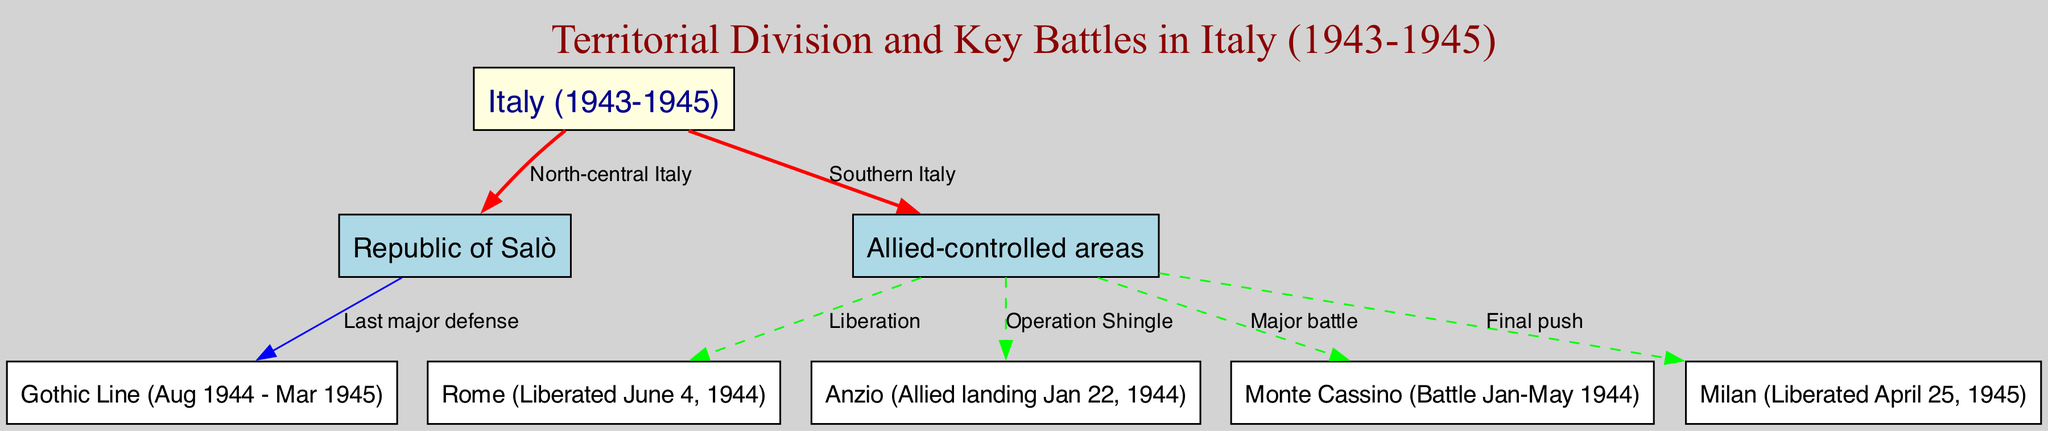What are the two main territorial divisions shown in the diagram? The diagram indicates two main territorial divisions: the Republic of Salò and Allied-controlled areas, which are clearly labeled in the nodes.
Answer: Republic of Salò and Allied-controlled areas How many key battle sites are identified in the diagram? The diagram lists four key battle sites: Rome, Anzio, Monte Cassino, and the Gothic Line as part of the representation of the conflict zones.
Answer: Four What was the date of the Allied landing at Anzio? According to the diagram, Anzio is marked as the location where the Allied landing occurred on January 22, 1944, which is directly noted next to the connecting edge.
Answer: January 22, 1944 Which area was liberated on April 25, 1945? The diagram indicates that Milan was liberated on April 25, 1945, shown by the edge connecting Allied-controlled areas to the Milan node with a specific label underlining this event.
Answer: Milan What was the timeframe of the Battle of Monte Cassino? The diagram specifies that the Battle of Monte Cassino took place from January to May 1944, which is noted clearly beside the respective node in the diagram.
Answer: January-May 1944 What color represents the nodes in the Allied-controlled areas? In the diagram, the nodes under Allied-controlled areas are filled with light blue color, which is the designated color for this category.
Answer: Light blue Which defense line is noted as the last major defense by the Republic of Salò? The Gothic Line is pointed out in the diagram as the last major defense line, connected to the Republic of Salò and highlighted in the edge label for clarity.
Answer: Gothic Line How is Rome categorized in the territorial divisions? The diagram categorizes Rome as an area liberated by the Allies, indicated through the label on its respective edge linked to Allied-controlled areas.
Answer: Liberated area What connection signifies the final push towards Milan? The edge labeled "Final push" signifies the connection from Allied-controlled areas to Milan, denoting a crucial phase in the liberation efforts as represented in the diagram.
Answer: Final push 